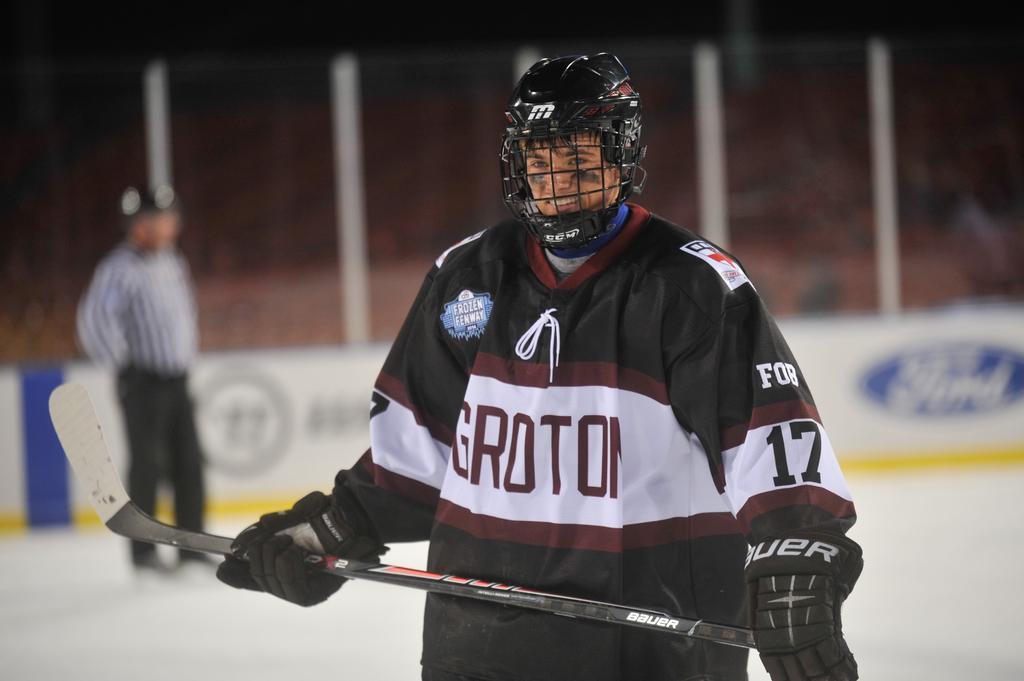Can you describe this image briefly? In this picture I can see there is a man standing here and he is wearing a jersey and holding a hockey stick, wearing a helmet and in the backdrop there are empty chairs. 